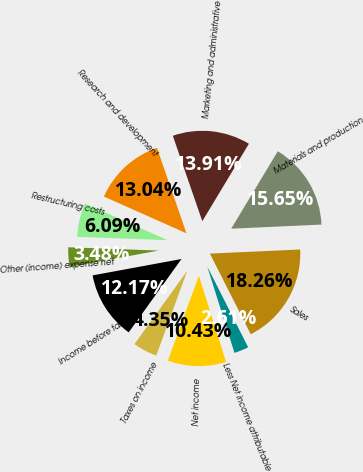Convert chart to OTSL. <chart><loc_0><loc_0><loc_500><loc_500><pie_chart><fcel>Sales<fcel>Materials and production<fcel>Marketing and administrative<fcel>Research and development<fcel>Restructuring costs<fcel>Other (income) expense net<fcel>Income before taxes<fcel>Taxes on income<fcel>Net income<fcel>Less Net income attributable<nl><fcel>18.26%<fcel>15.65%<fcel>13.91%<fcel>13.04%<fcel>6.09%<fcel>3.48%<fcel>12.17%<fcel>4.35%<fcel>10.43%<fcel>2.61%<nl></chart> 